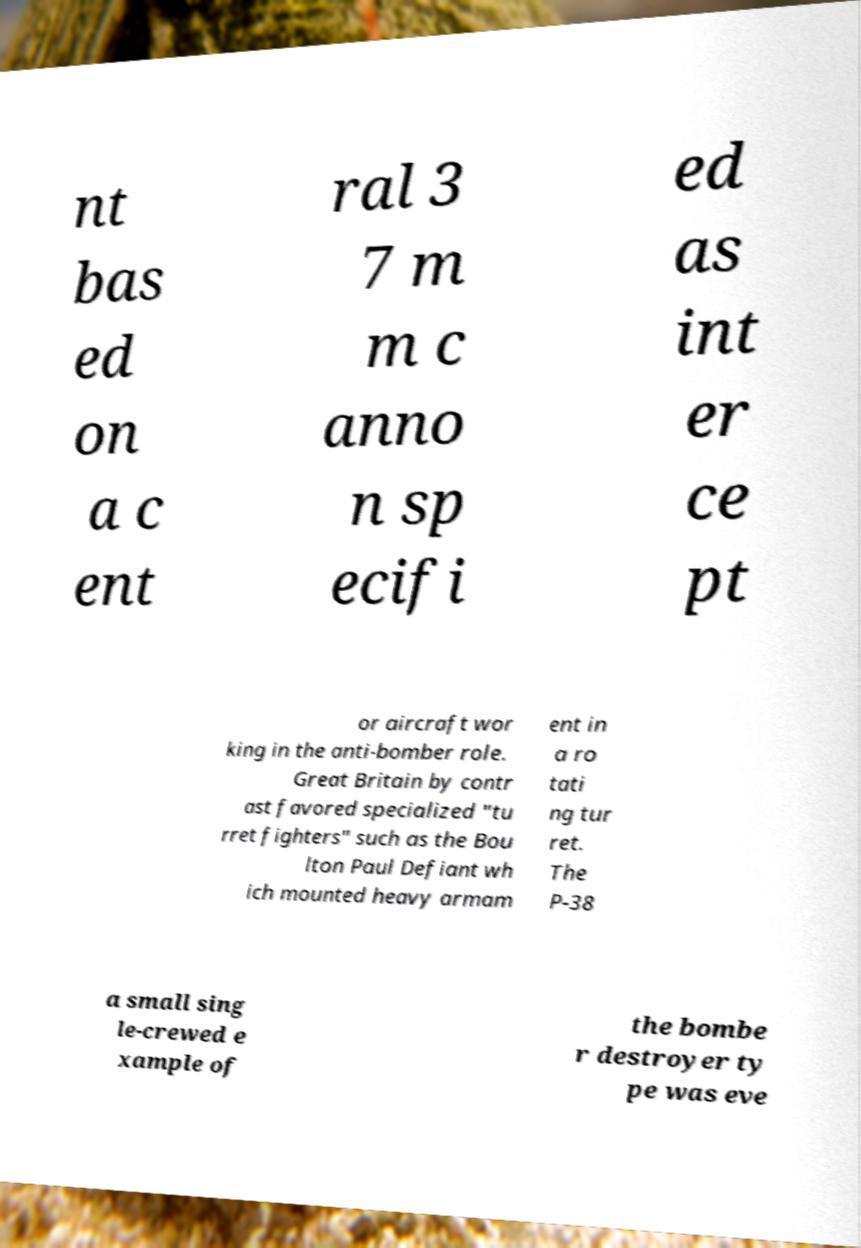Please read and relay the text visible in this image. What does it say? nt bas ed on a c ent ral 3 7 m m c anno n sp ecifi ed as int er ce pt or aircraft wor king in the anti-bomber role. Great Britain by contr ast favored specialized "tu rret fighters" such as the Bou lton Paul Defiant wh ich mounted heavy armam ent in a ro tati ng tur ret. The P-38 a small sing le-crewed e xample of the bombe r destroyer ty pe was eve 